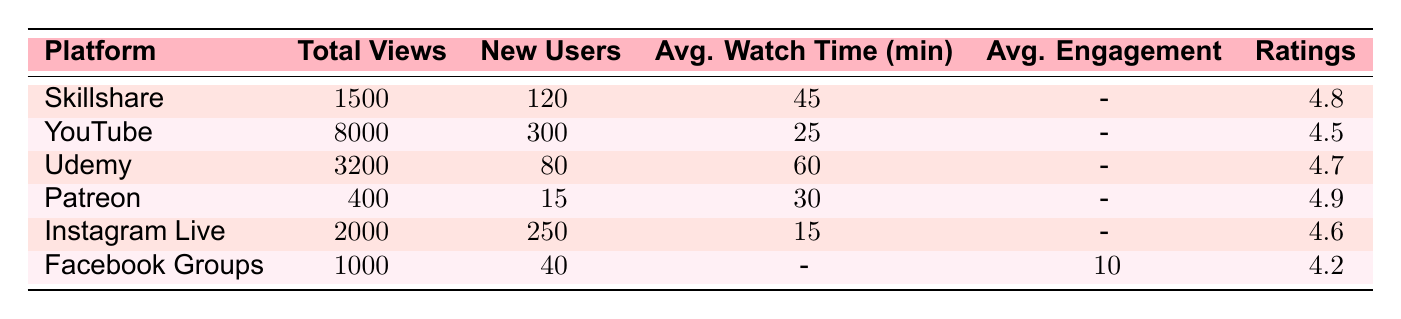What platform had the highest total views? The total views for each platform are listed in the table. Examining the "Total Views" column, YouTube shows the highest number with 8000 views.
Answer: YouTube How many new students did Udemy acquire? In the table, the "New Students" column for Udemy shows a value of 80.
Answer: 80 Which platform has the lowest average watch time? By looking at the "Average Watch Time (min)" column, Instagram Live has the lowest value at 15 minutes.
Answer: Instagram Live What is the average watch time of all listed platforms? To find the average watch time, sum the average watch times of each platform: (45 + 25 + 60 + 30 + 15)/5 = 175/5 = 35.
Answer: 35 Is the rating of Skillshare higher than that of Instagram Live? Comparing the "Ratings" column, Skillshare has a rating of 4.8 while Instagram Live has 4.6. Since 4.8 is greater than 4.6, the statement is true.
Answer: Yes What is the difference in total views between Skillshare and Facebook Groups? The total views for Skillshare is 1500 and for Facebook Groups is 1000. Calculating the difference: 1500 - 1000 = 500.
Answer: 500 How many new users did Patreon gain? In the table, the "New Users" column for Patreon indicates 15 new patrons.
Answer: 15 Which platform had an average rating below 4.6? By examining the "Ratings" column, we see that Facebook Groups has a rating of 4.2, which is below 4.6.
Answer: Facebook Groups If we consider the average rating of Skillshare, Udemy, and Patreon, is it greater than 4.7? The ratings for Skillshare, Udemy, and Patreon are 4.8, 4.7, and 4.9 respectively. The average is (4.8 + 4.7 + 4.9) / 3 = 4.8. Since 4.8 is greater than 4.7, the answer is yes.
Answer: Yes 